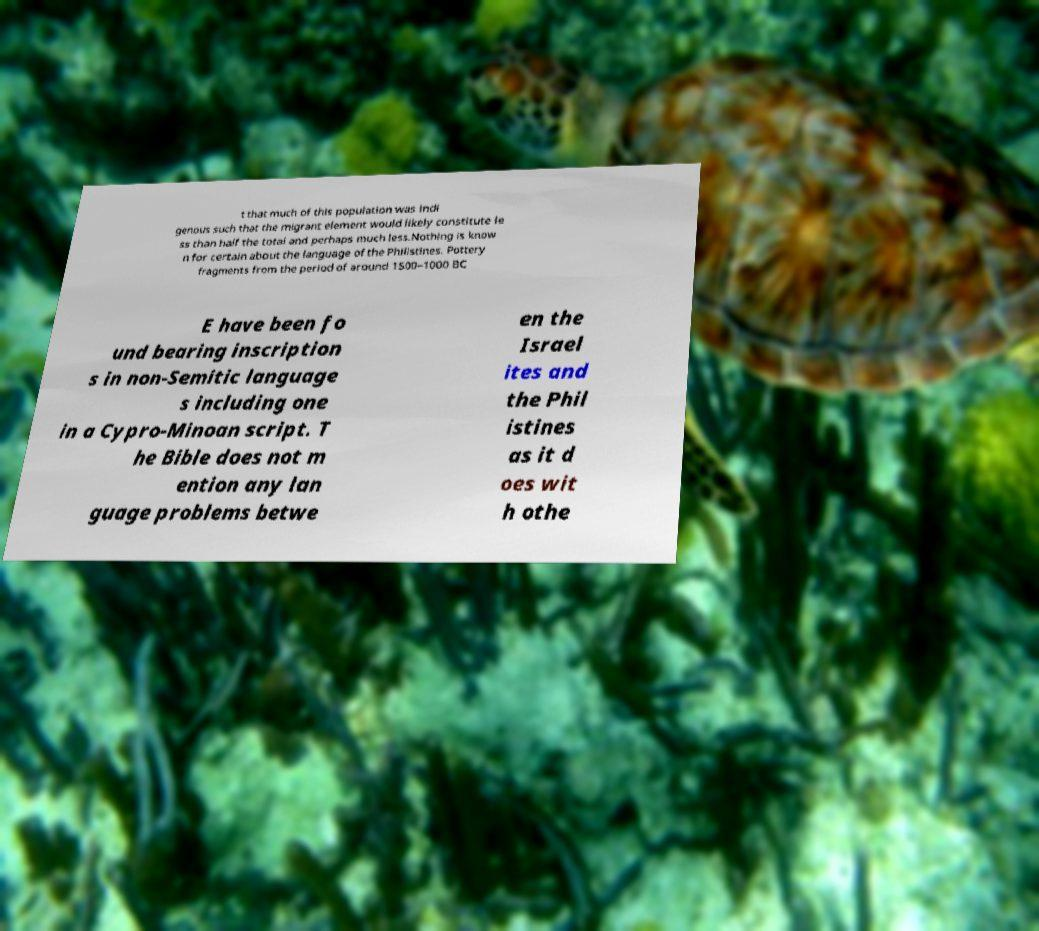Please read and relay the text visible in this image. What does it say? t that much of this population was indi genous such that the migrant element would likely constitute le ss than half the total and perhaps much less.Nothing is know n for certain about the language of the Philistines. Pottery fragments from the period of around 1500–1000 BC E have been fo und bearing inscription s in non-Semitic language s including one in a Cypro-Minoan script. T he Bible does not m ention any lan guage problems betwe en the Israel ites and the Phil istines as it d oes wit h othe 